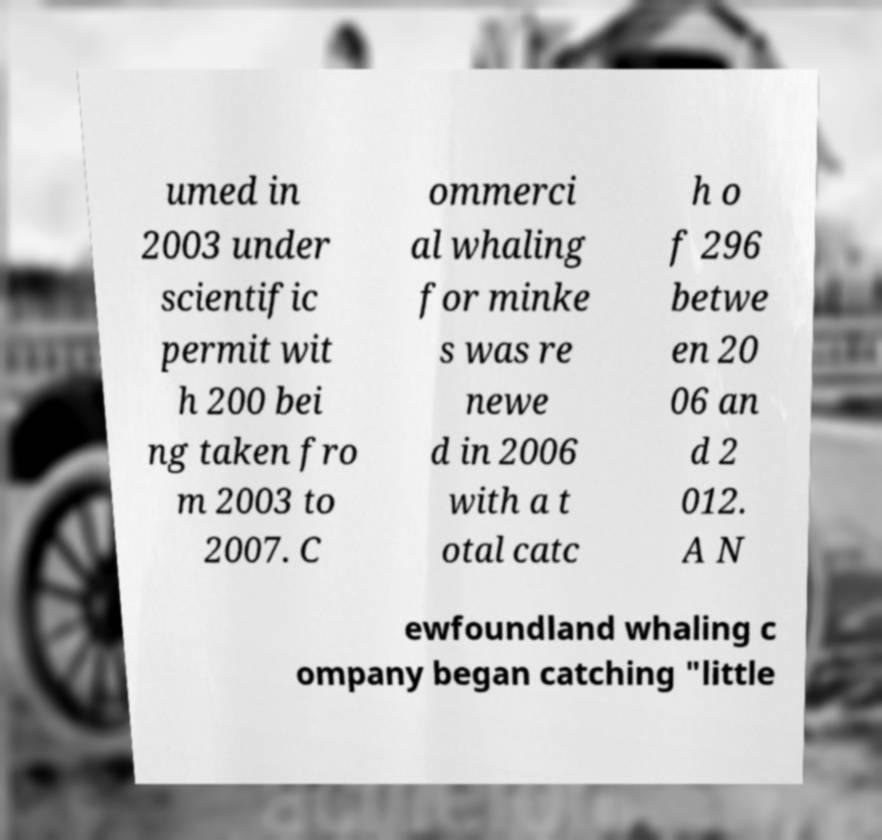Can you accurately transcribe the text from the provided image for me? umed in 2003 under scientific permit wit h 200 bei ng taken fro m 2003 to 2007. C ommerci al whaling for minke s was re newe d in 2006 with a t otal catc h o f 296 betwe en 20 06 an d 2 012. A N ewfoundland whaling c ompany began catching "little 